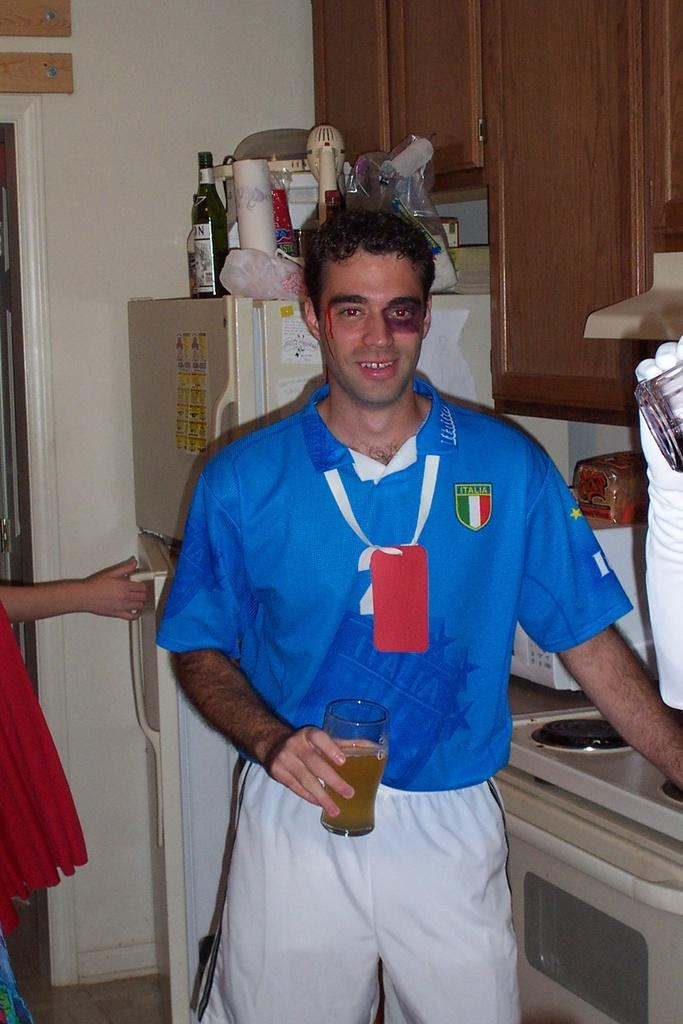<image>
Create a compact narrative representing the image presented. Man with a black eye wearing a shirt with Italia on left side of chest. 